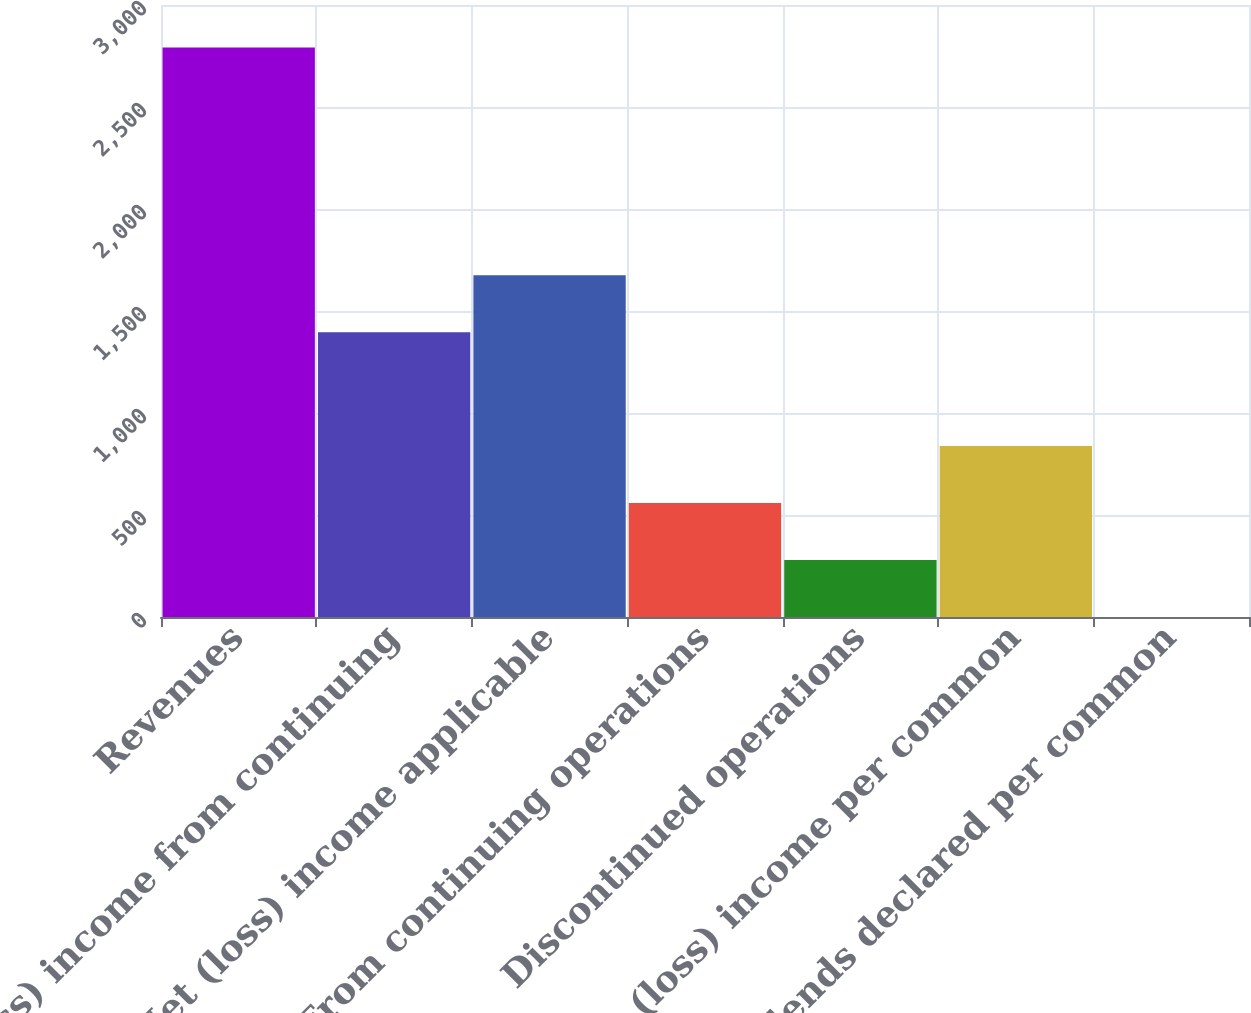Convert chart to OTSL. <chart><loc_0><loc_0><loc_500><loc_500><bar_chart><fcel>Revenues<fcel>(Loss) income from continuing<fcel>Net (loss) income applicable<fcel>From continuing operations<fcel>Discontinued operations<fcel>Net (loss) income per common<fcel>Dividends declared per common<nl><fcel>2792<fcel>1396.07<fcel>1675.25<fcel>558.53<fcel>279.35<fcel>837.71<fcel>0.17<nl></chart> 